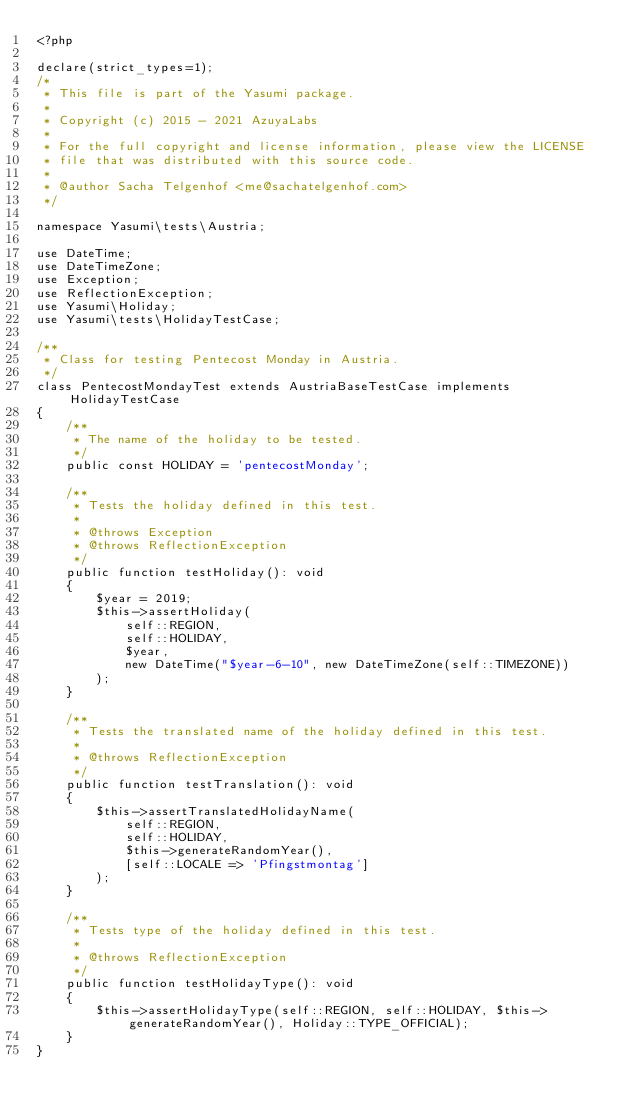<code> <loc_0><loc_0><loc_500><loc_500><_PHP_><?php

declare(strict_types=1);
/*
 * This file is part of the Yasumi package.
 *
 * Copyright (c) 2015 - 2021 AzuyaLabs
 *
 * For the full copyright and license information, please view the LICENSE
 * file that was distributed with this source code.
 *
 * @author Sacha Telgenhof <me@sachatelgenhof.com>
 */

namespace Yasumi\tests\Austria;

use DateTime;
use DateTimeZone;
use Exception;
use ReflectionException;
use Yasumi\Holiday;
use Yasumi\tests\HolidayTestCase;

/**
 * Class for testing Pentecost Monday in Austria.
 */
class PentecostMondayTest extends AustriaBaseTestCase implements HolidayTestCase
{
    /**
     * The name of the holiday to be tested.
     */
    public const HOLIDAY = 'pentecostMonday';

    /**
     * Tests the holiday defined in this test.
     *
     * @throws Exception
     * @throws ReflectionException
     */
    public function testHoliday(): void
    {
        $year = 2019;
        $this->assertHoliday(
            self::REGION,
            self::HOLIDAY,
            $year,
            new DateTime("$year-6-10", new DateTimeZone(self::TIMEZONE))
        );
    }

    /**
     * Tests the translated name of the holiday defined in this test.
     *
     * @throws ReflectionException
     */
    public function testTranslation(): void
    {
        $this->assertTranslatedHolidayName(
            self::REGION,
            self::HOLIDAY,
            $this->generateRandomYear(),
            [self::LOCALE => 'Pfingstmontag']
        );
    }

    /**
     * Tests type of the holiday defined in this test.
     *
     * @throws ReflectionException
     */
    public function testHolidayType(): void
    {
        $this->assertHolidayType(self::REGION, self::HOLIDAY, $this->generateRandomYear(), Holiday::TYPE_OFFICIAL);
    }
}
</code> 